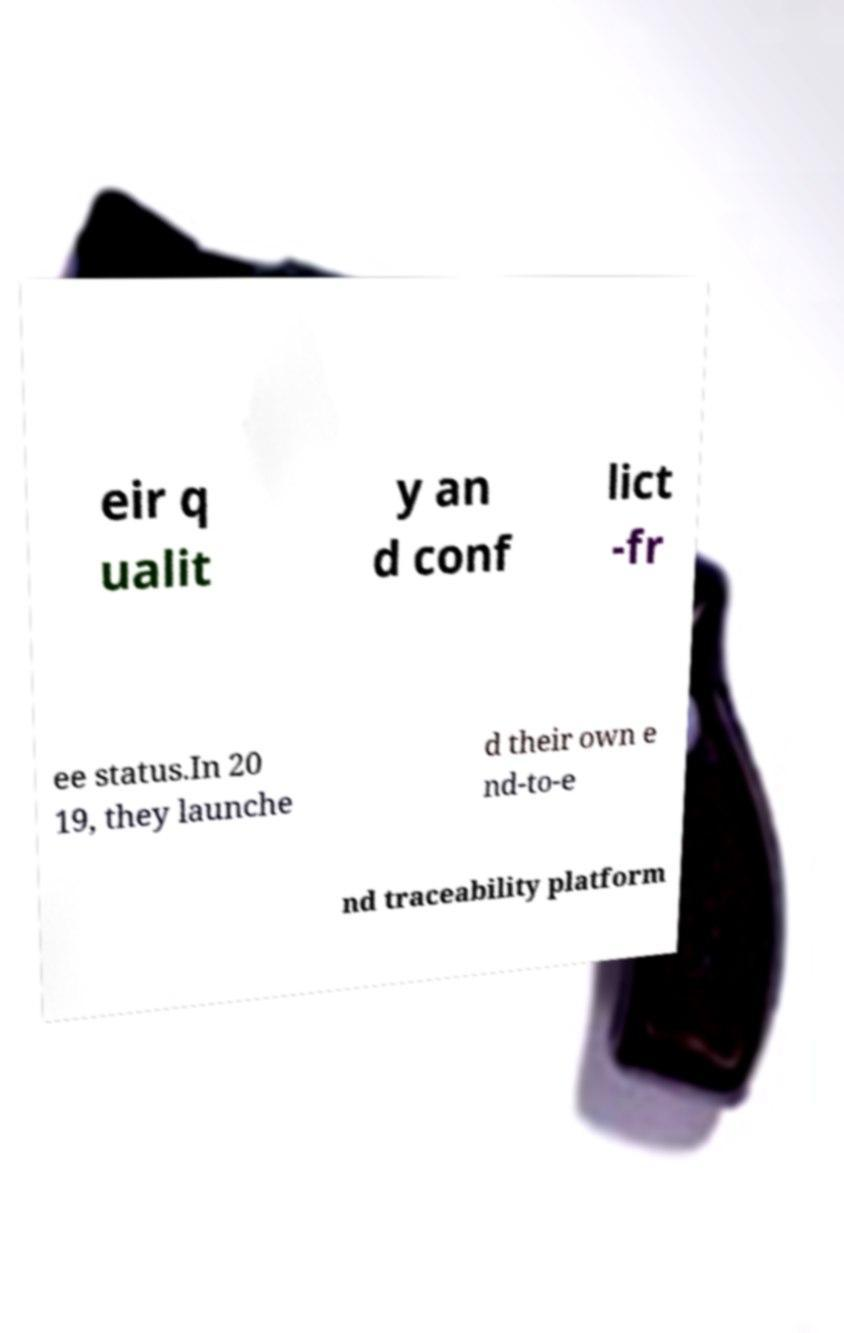What messages or text are displayed in this image? I need them in a readable, typed format. eir q ualit y an d conf lict -fr ee status.In 20 19, they launche d their own e nd-to-e nd traceability platform 